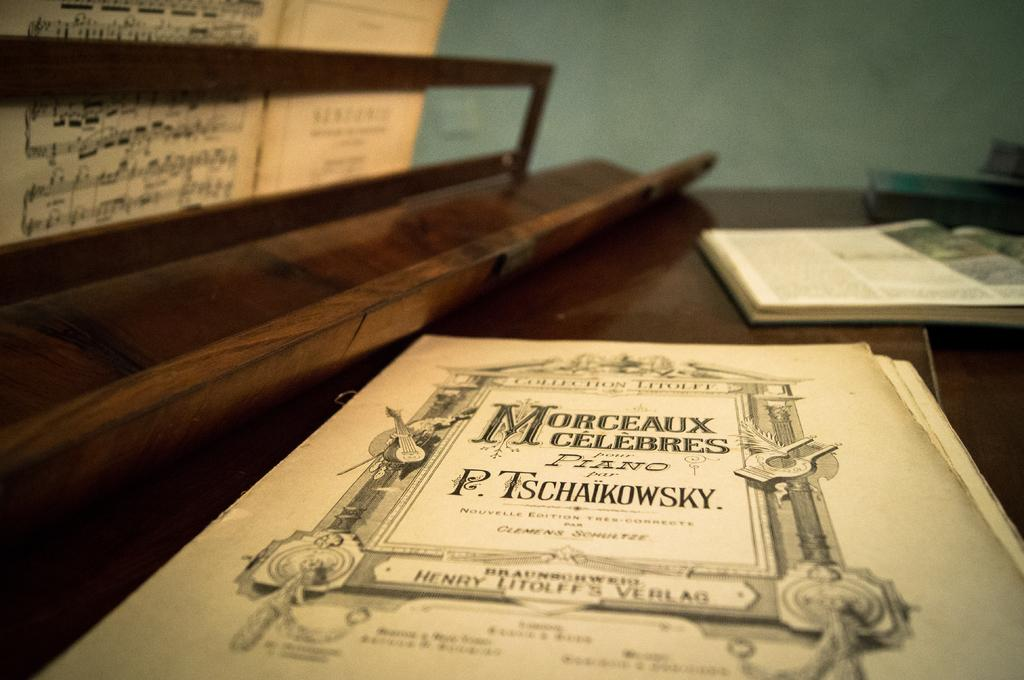<image>
Provide a brief description of the given image. Book on a table with the name "P. Tschaikowsky" on the front. 